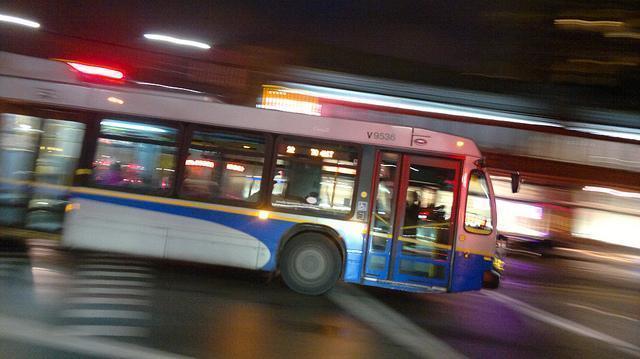Why is the bus blurred in the picture?
Select the accurate answer and provide explanation: 'Answer: answer
Rationale: rationale.'
Options: Cloudy lens, moving fast, flickering lights, wet paint. Answer: moving fast.
Rationale: Speed can blur things when you are standing still. 